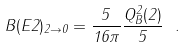Convert formula to latex. <formula><loc_0><loc_0><loc_500><loc_500>B ( E 2 ) _ { 2 \rightarrow 0 } = \frac { 5 } { 1 6 \pi } \frac { Q ^ { 2 } _ { B } ( 2 ) } { 5 } \ .</formula> 